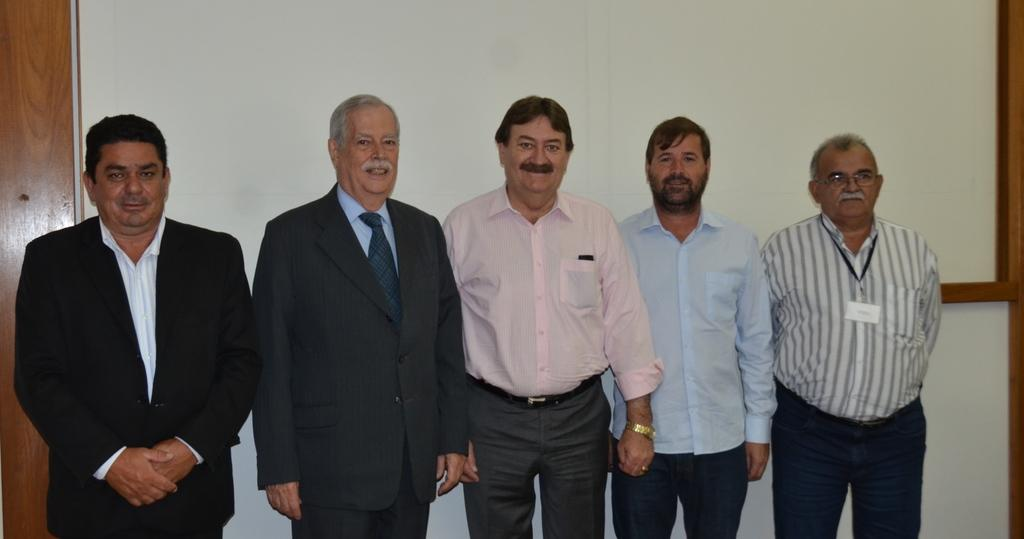What is happening in the middle of the image? There are people standing in the middle of the image. How are the people in the image feeling? The people are smiling in the image. What can be seen in the background of the image? There is a wall in the background of the image. What type of cakes are being sold by the people in the image? There is no indication in the image that the people are selling cakes or any other items. 